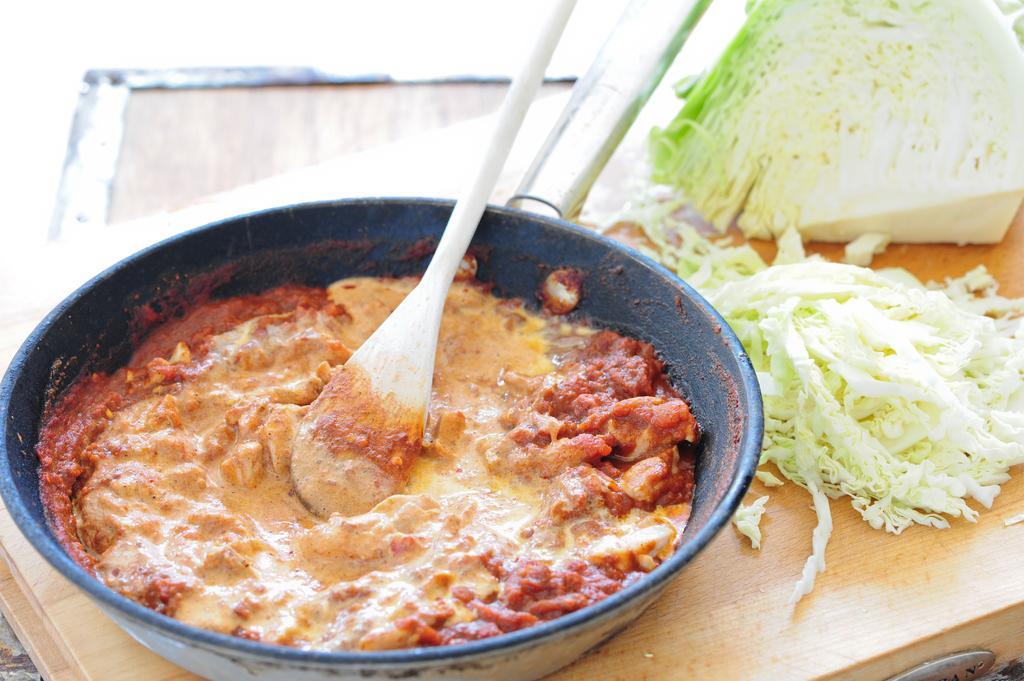In one or two sentences, can you explain what this image depicts? In this image, we can see some food and spatula in the cooking pan. This pin is placed on the wooden surface. On the right side of the image, eatable things. Right side bottom corner, we can see silver color object. Top of the image, there is a surface and handle. 